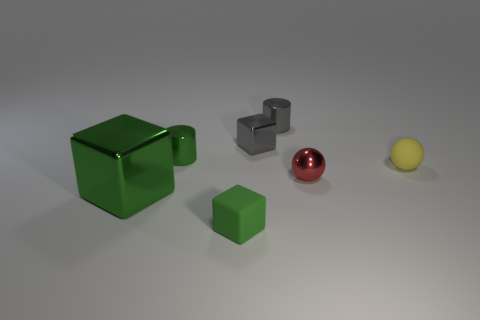Is there a metal cylinder in front of the metallic cylinder on the right side of the rubber object in front of the red ball?
Make the answer very short. Yes. Is there any other thing that has the same shape as the big metal object?
Provide a succinct answer. Yes. Are any small cyan matte balls visible?
Make the answer very short. No. Is the material of the green cylinder that is on the left side of the tiny rubber sphere the same as the tiny thing behind the small metal cube?
Provide a succinct answer. Yes. What size is the matte object that is behind the small rubber object to the left of the small cube behind the green matte thing?
Make the answer very short. Small. What number of other objects are made of the same material as the tiny yellow object?
Offer a very short reply. 1. Is the number of yellow rubber spheres less than the number of big red metallic cylinders?
Make the answer very short. No. There is another green object that is the same shape as the tiny green matte thing; what size is it?
Provide a succinct answer. Large. Is the material of the small thing right of the red metallic object the same as the small green block?
Offer a very short reply. Yes. Is the shape of the small green rubber thing the same as the large green shiny thing?
Provide a short and direct response. Yes. 